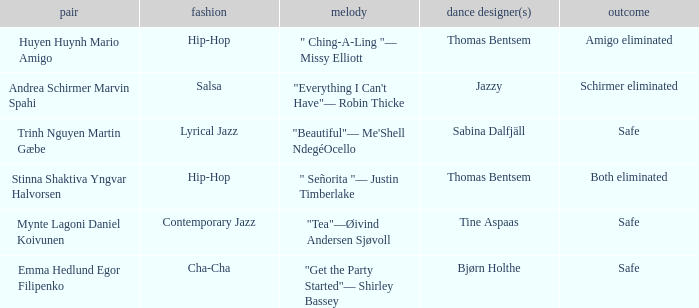What is the music for choreographer sabina dalfjäll? "Beautiful"— Me'Shell NdegéOcello. 